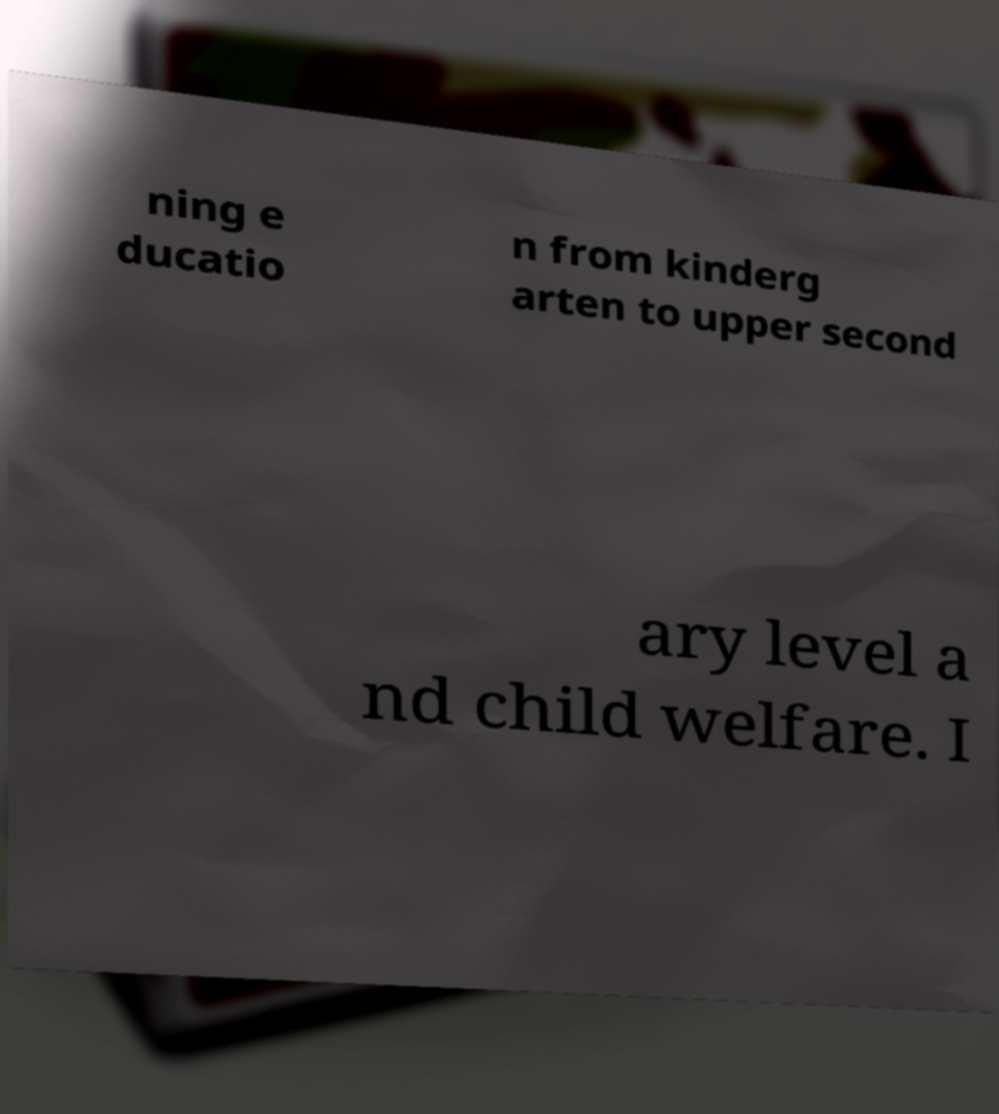Could you extract and type out the text from this image? ning e ducatio n from kinderg arten to upper second ary level a nd child welfare. I 